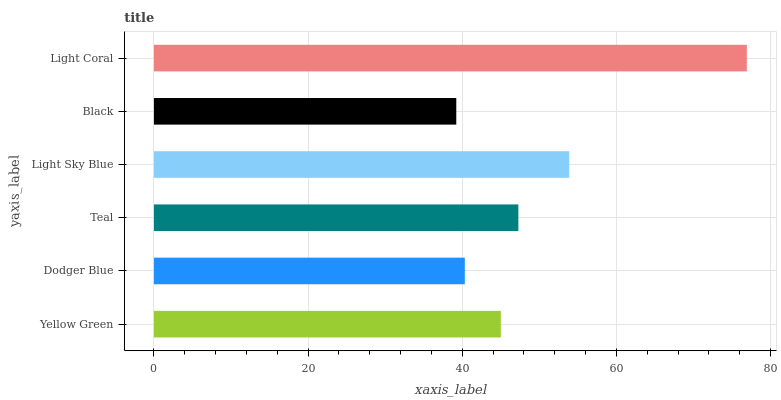Is Black the minimum?
Answer yes or no. Yes. Is Light Coral the maximum?
Answer yes or no. Yes. Is Dodger Blue the minimum?
Answer yes or no. No. Is Dodger Blue the maximum?
Answer yes or no. No. Is Yellow Green greater than Dodger Blue?
Answer yes or no. Yes. Is Dodger Blue less than Yellow Green?
Answer yes or no. Yes. Is Dodger Blue greater than Yellow Green?
Answer yes or no. No. Is Yellow Green less than Dodger Blue?
Answer yes or no. No. Is Teal the high median?
Answer yes or no. Yes. Is Yellow Green the low median?
Answer yes or no. Yes. Is Yellow Green the high median?
Answer yes or no. No. Is Black the low median?
Answer yes or no. No. 